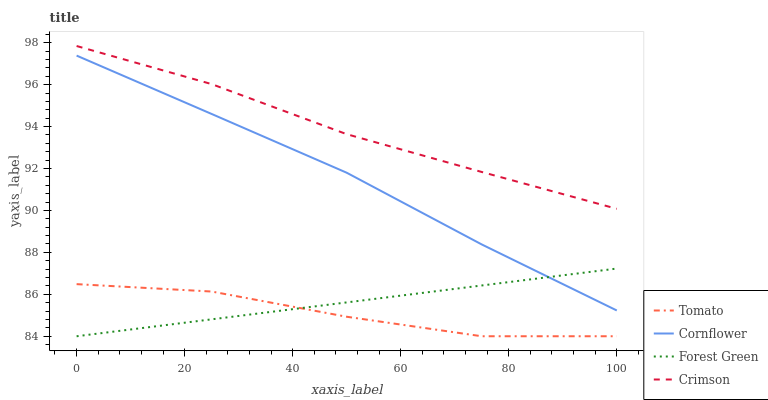Does Tomato have the minimum area under the curve?
Answer yes or no. Yes. Does Crimson have the maximum area under the curve?
Answer yes or no. Yes. Does Cornflower have the minimum area under the curve?
Answer yes or no. No. Does Cornflower have the maximum area under the curve?
Answer yes or no. No. Is Forest Green the smoothest?
Answer yes or no. Yes. Is Tomato the roughest?
Answer yes or no. Yes. Is Cornflower the smoothest?
Answer yes or no. No. Is Cornflower the roughest?
Answer yes or no. No. Does Tomato have the lowest value?
Answer yes or no. Yes. Does Cornflower have the lowest value?
Answer yes or no. No. Does Crimson have the highest value?
Answer yes or no. Yes. Does Cornflower have the highest value?
Answer yes or no. No. Is Cornflower less than Crimson?
Answer yes or no. Yes. Is Crimson greater than Forest Green?
Answer yes or no. Yes. Does Forest Green intersect Cornflower?
Answer yes or no. Yes. Is Forest Green less than Cornflower?
Answer yes or no. No. Is Forest Green greater than Cornflower?
Answer yes or no. No. Does Cornflower intersect Crimson?
Answer yes or no. No. 